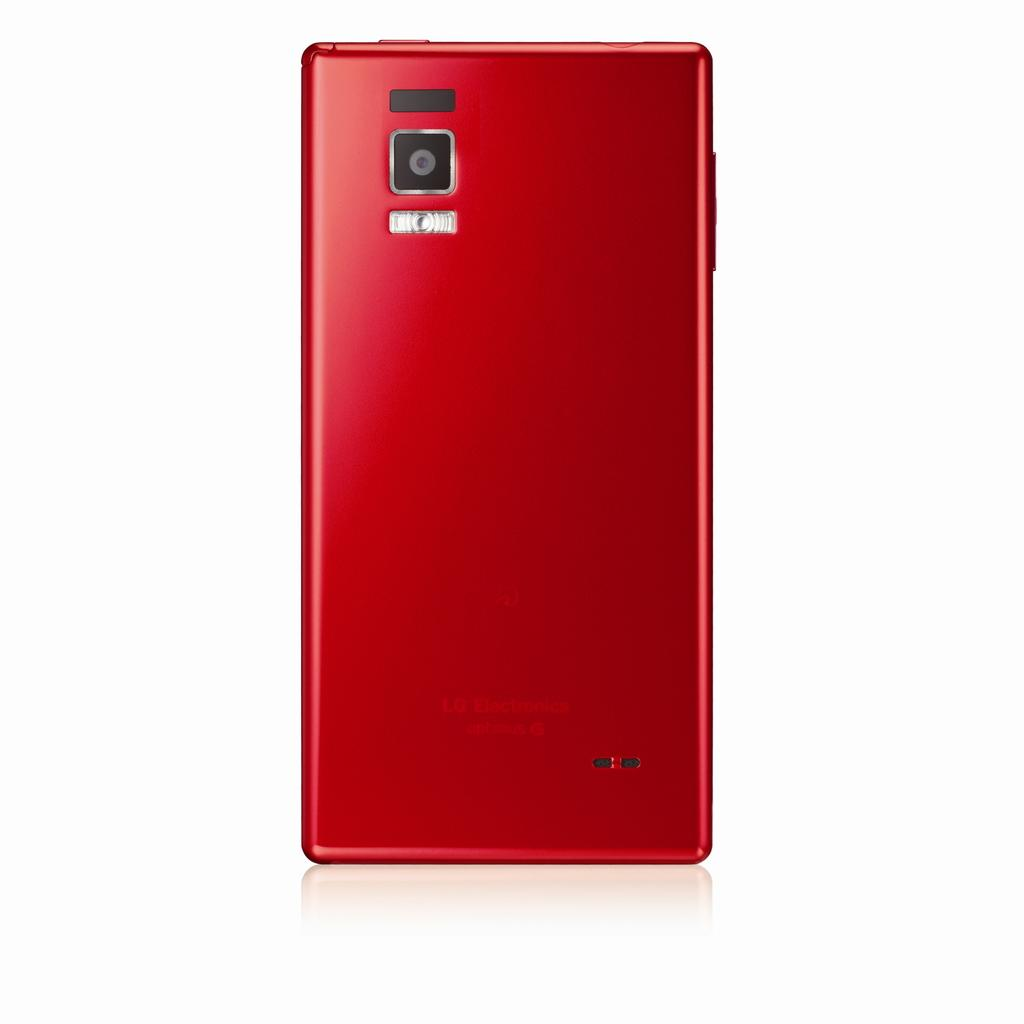Provide a one-sentence caption for the provided image. The back of an LG phone is shown in red. 